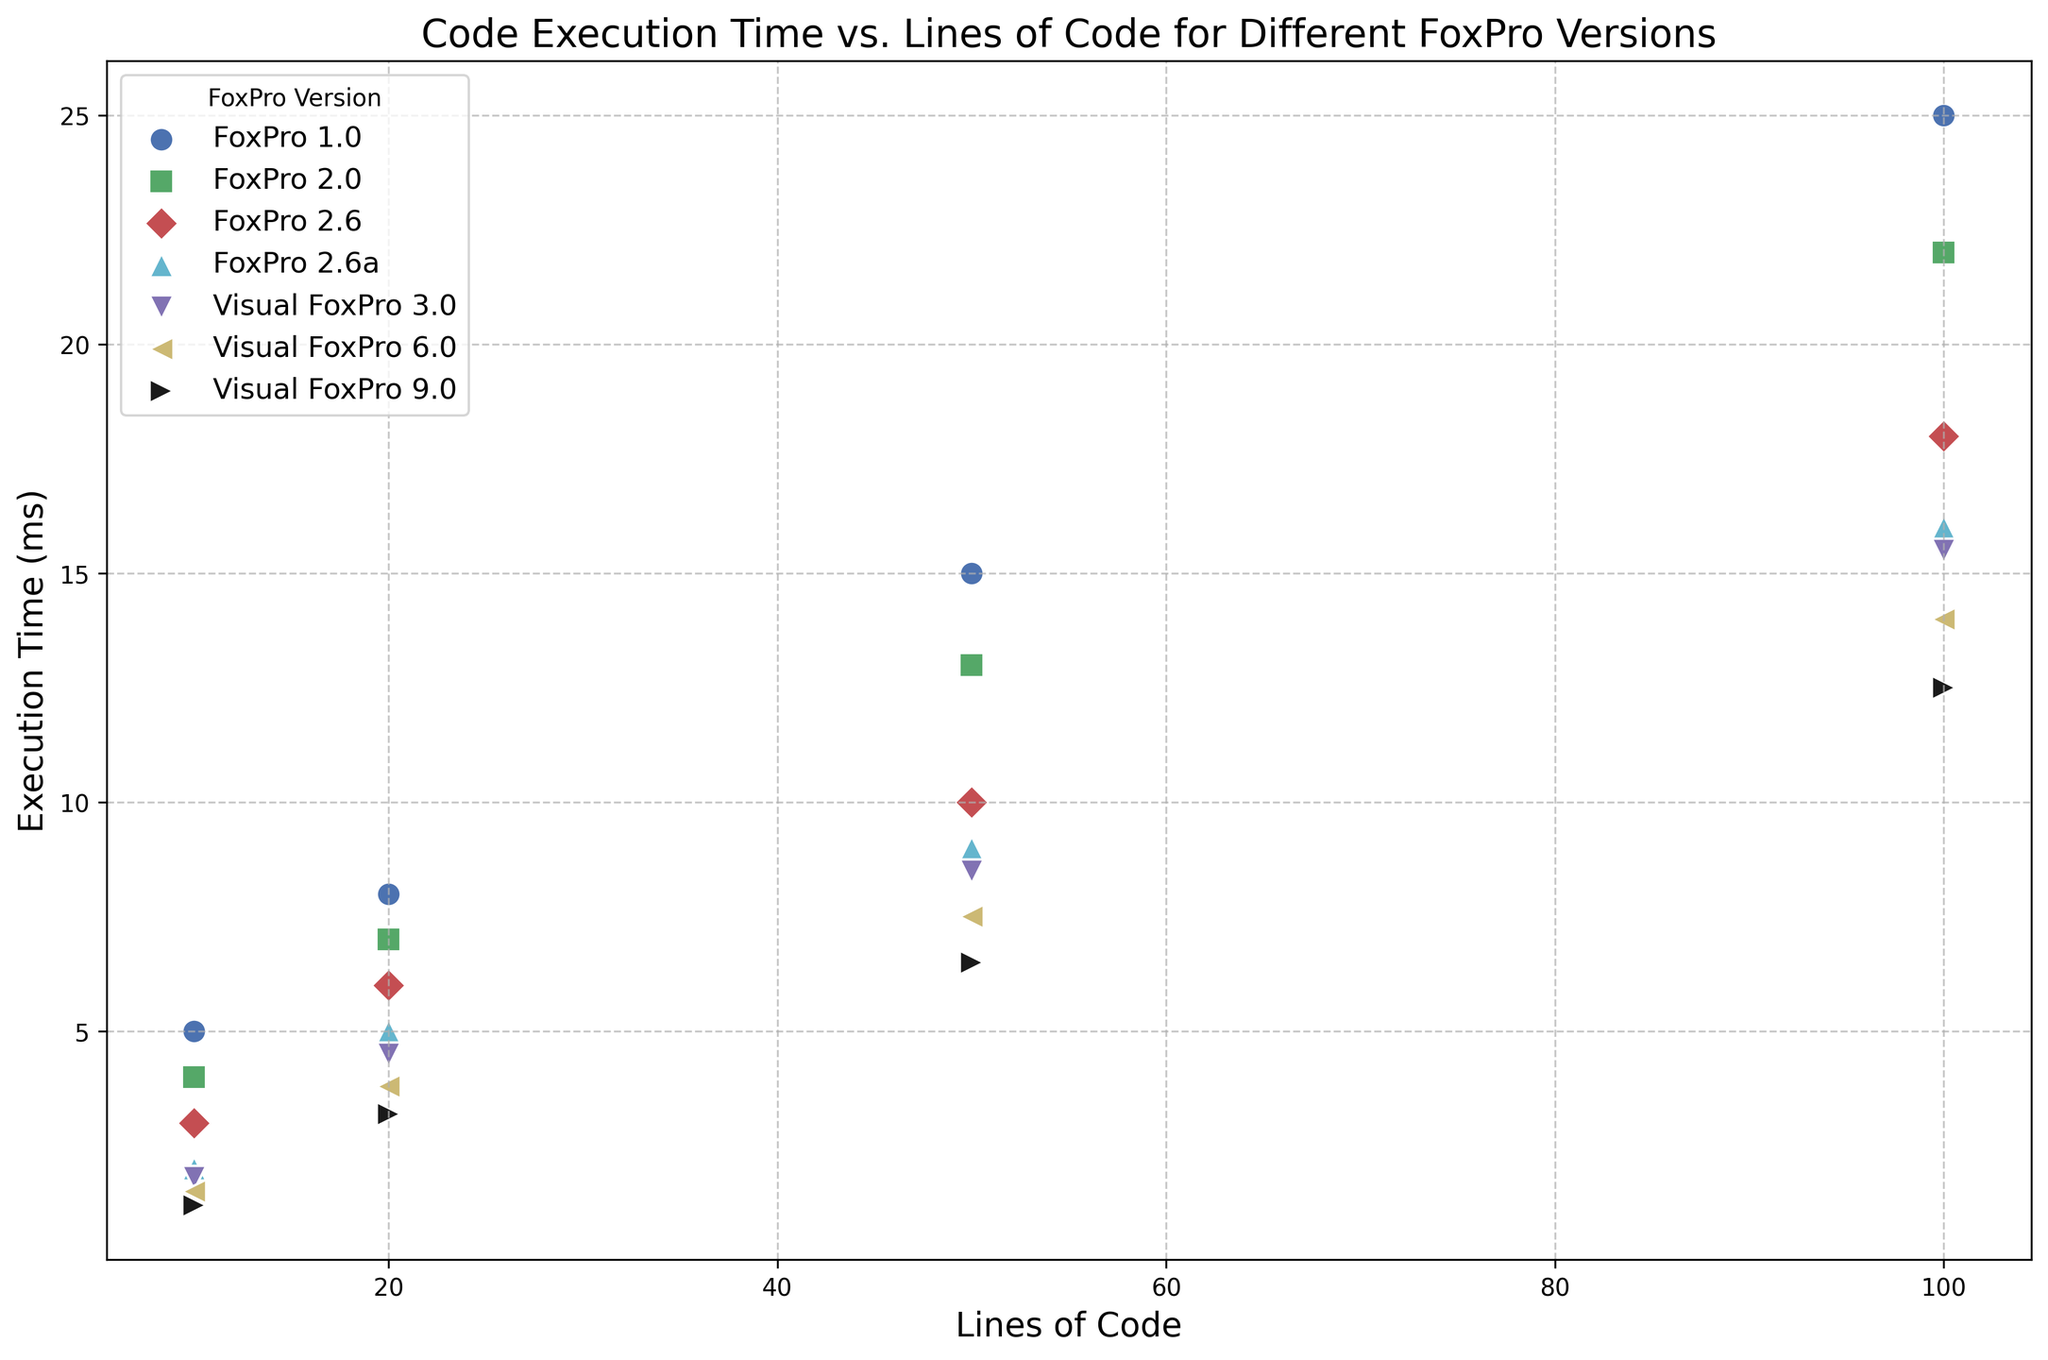Which FoxPro version has the lowest execution time for 10 lines of code? By examining the scatter plot, we can look at the points corresponding to 10 lines of code for each version and find the lowest point on the y-axis. Visual FoxPro 9.0 appears to have the lowest execution time for 10 lines of code.
Answer: Visual FoxPro 9.0 Which FoxPro version demonstrates the most significant performance improvement from FoxPro 1.0 to its latest version? To determine this, compare the execution times of FoxPro 1.0 and Visual FoxPro 9.0 across different lines of code. Visually, the reduction in execution time is most significant in Visual FoxPro 9.0.
Answer: Visual FoxPro 9.0 What is the average execution time of FoxPro 2.6 for 20, 50, and 100 lines of code? Sum the execution times for FoxPro 2.6 at 20, 50, and 100 lines (6, 10, and 18 ms) and then divide by the number of data points: (6 + 10 + 18) / 3 = 34 / 3 = 11.33 ms.
Answer: 11.33 ms Which version shows the least variability in execution time as the lines of code increase? By observing the scatter plot, find the version whose points form the flattest line. FoxPro 2.6a shows the least increase in execution time as the lines of code increase.
Answer: FoxPro 2.6a Does Visual FoxPro 3.0 or Visual FoxPro 6.0 have a faster execution time for 50 lines of code? Compare the y-values of the points corresponding to 50 lines of code for Visual FoxPro 3.0 and Visual FoxPro 6.0. Visual FoxPro 6.0 has a faster execution time (7.5 ms) than Visual FoxPro 3.0 (8.5 ms).
Answer: Visual FoxPro 6.0 How does the execution time for FoxPro 1.0 at 100 lines of code compare to Visual FoxPro 9.0 at the same code length? Compare the y-values of the points for 100 lines of code for both FoxPro 1.0 and Visual FoxPro 9.0. FoxPro 1.0 has an execution time of 25 ms, while Visual FoxPro 9.0 has 12.5 ms.
Answer: FoxPro 1.0 is slower Would you say Visual FoxPro versions generally have faster execution times than FoxPro versions? By looking at the scatter plot, generally, the Visual FoxPro versions (3.0, 6.0, 9.0) have lower points compared to the earlier FoxPro versions (1.0, 2.0, 2.6), indicating faster execution times.
Answer: Yes Which FoxPro version shows the smallest execution time at 20 lines of code? Locate the points at 20 lines of code for each version and find the point with the smallest y-value. Visual FoxPro 9.0 has the smallest execution time at 20 lines of code (3.2 ms).
Answer: Visual FoxPro 9.0 